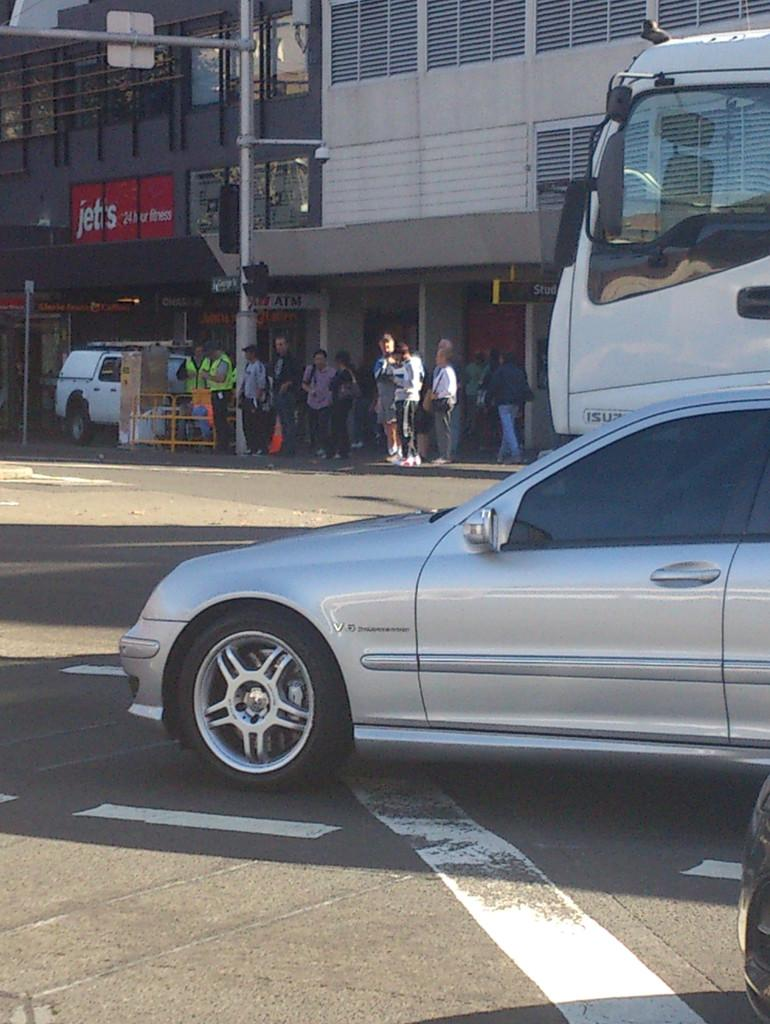What type of view is shown in the image? The image is an outside view. What can be seen on the right side of the image? There are vehicles on the road on the right side of the image. What is happening in the background of the image? There are people standing on the footpath and a building is visible in the background of the image. What type of land is being discovered in the image? There is no indication of any land discovery in the image; it shows an outside view with vehicles, people, and a building. What veil is being lifted in the image? There is no veil present in the image; it features an outside view with vehicles, people, and a building. 